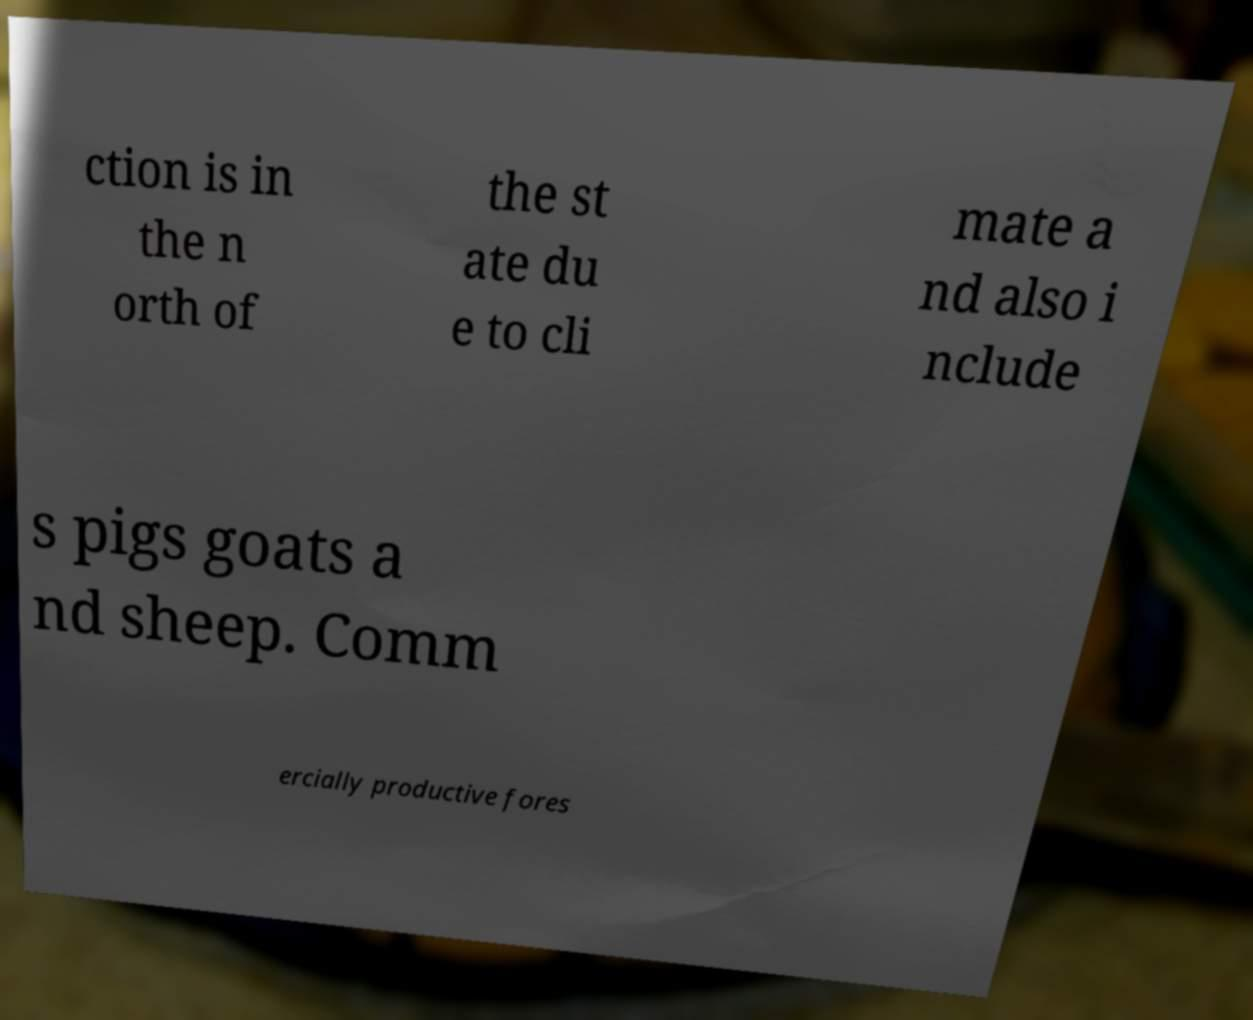Can you accurately transcribe the text from the provided image for me? ction is in the n orth of the st ate du e to cli mate a nd also i nclude s pigs goats a nd sheep. Comm ercially productive fores 